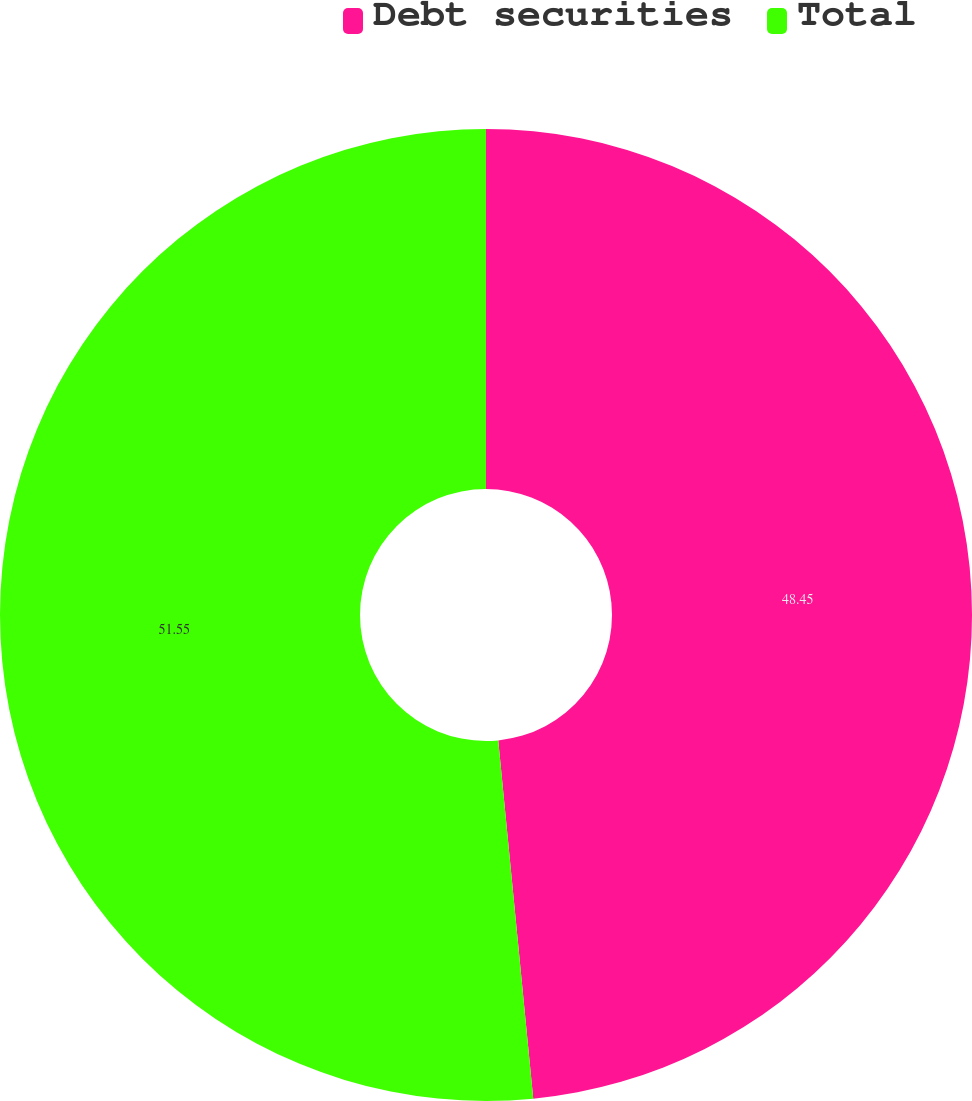<chart> <loc_0><loc_0><loc_500><loc_500><pie_chart><fcel>Debt securities<fcel>Total<nl><fcel>48.45%<fcel>51.55%<nl></chart> 